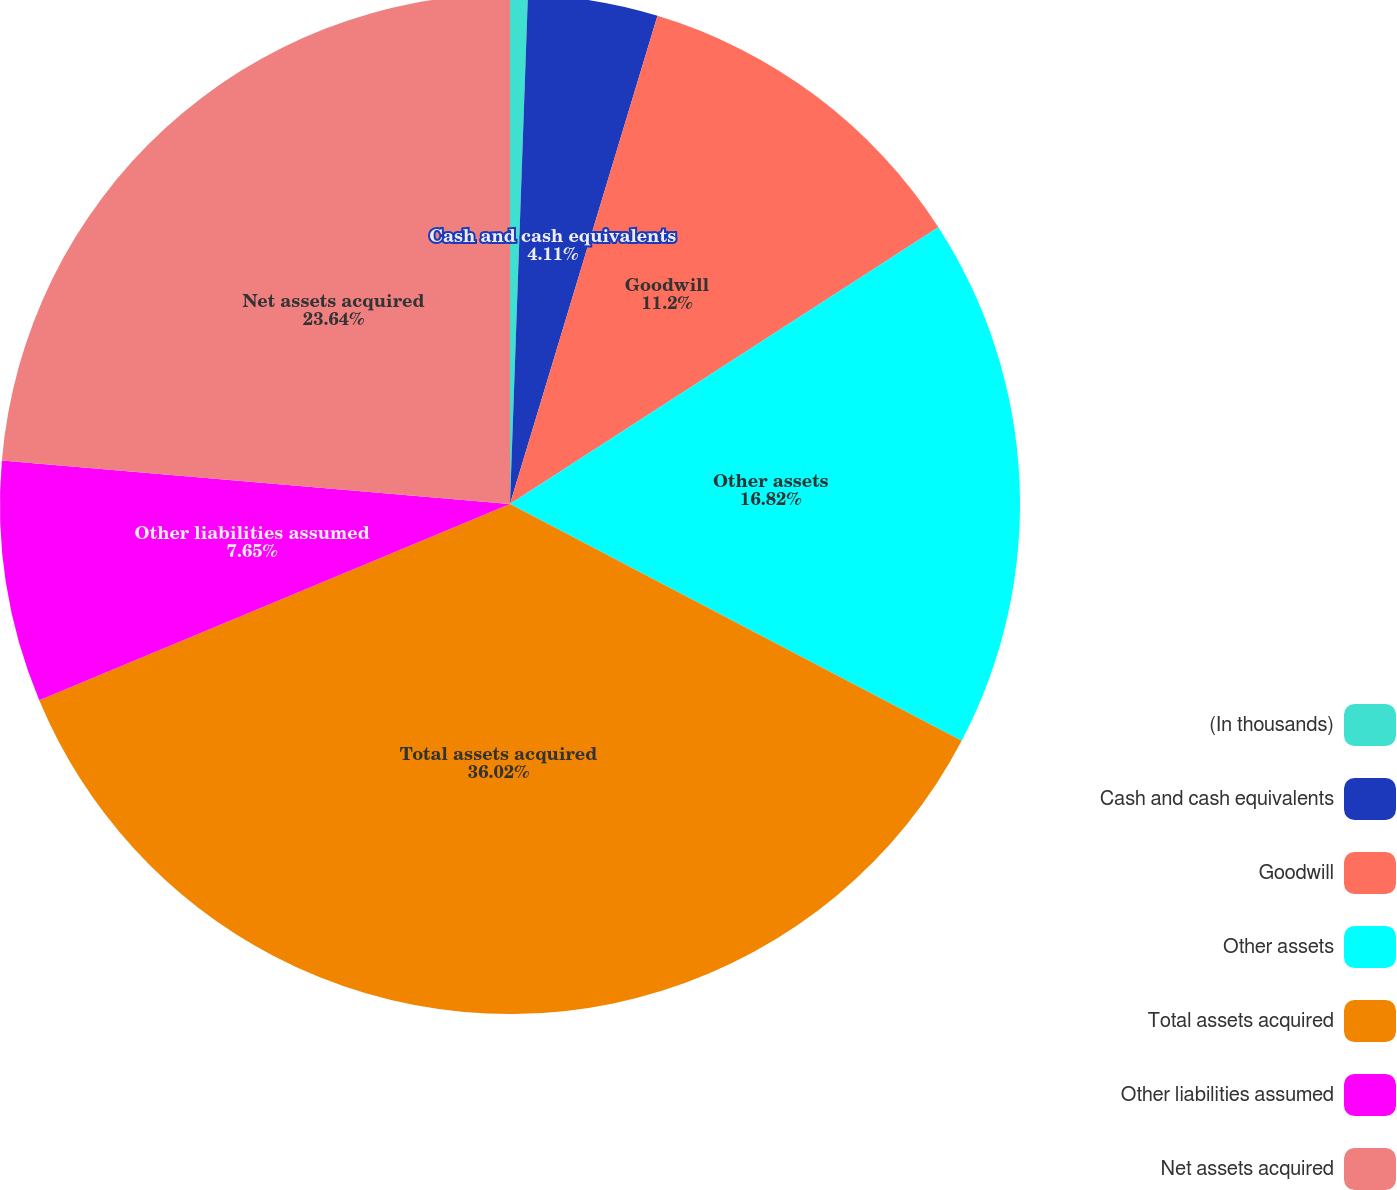Convert chart to OTSL. <chart><loc_0><loc_0><loc_500><loc_500><pie_chart><fcel>(In thousands)<fcel>Cash and cash equivalents<fcel>Goodwill<fcel>Other assets<fcel>Total assets acquired<fcel>Other liabilities assumed<fcel>Net assets acquired<nl><fcel>0.56%<fcel>4.11%<fcel>11.2%<fcel>16.82%<fcel>36.03%<fcel>7.65%<fcel>23.64%<nl></chart> 